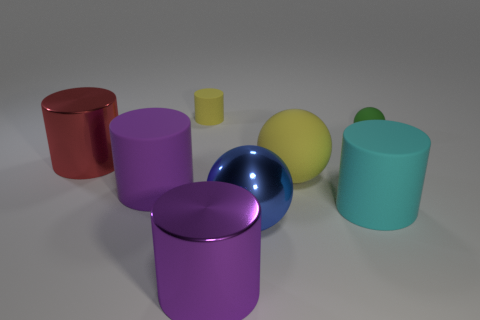What might the purpose of these objects be? The objects appear to be digitally rendered models used to demonstrate 3D rendering techniques such as lighting, shading, and reflections. They could serve educational or visualization purposes, showcasing how different shapes and colors interact with a simulated light source in a virtual environment. 